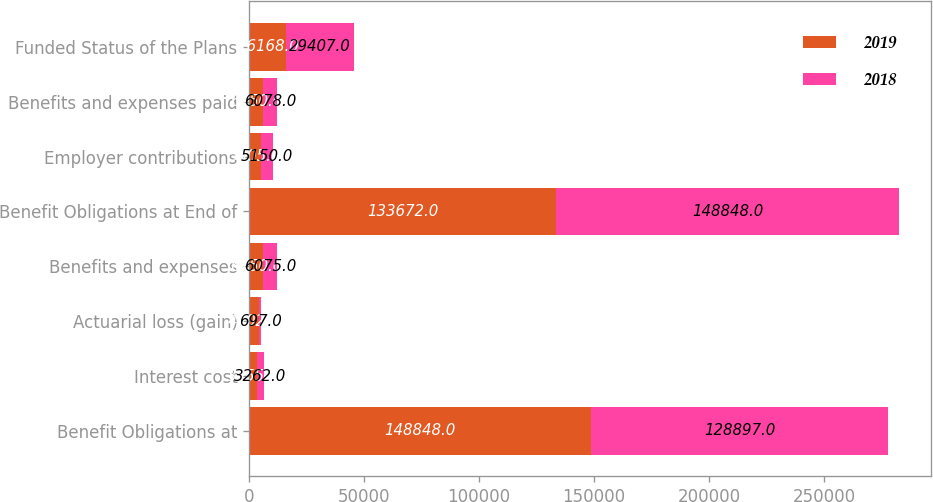Convert chart to OTSL. <chart><loc_0><loc_0><loc_500><loc_500><stacked_bar_chart><ecel><fcel>Benefit Obligations at<fcel>Interest cost<fcel>Actuarial loss (gain)<fcel>Benefits and expenses<fcel>Benefit Obligations at End of<fcel>Employer contributions<fcel>Benefits and expenses paid<fcel>Funded Status of the Plans<nl><fcel>2019<fcel>148848<fcel>3255<fcel>4402<fcel>6150<fcel>133672<fcel>5005<fcel>6150<fcel>16168<nl><fcel>2018<fcel>128897<fcel>3262<fcel>697<fcel>6075<fcel>148848<fcel>5150<fcel>6078<fcel>29407<nl></chart> 